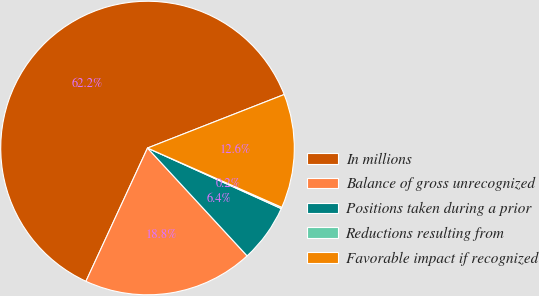<chart> <loc_0><loc_0><loc_500><loc_500><pie_chart><fcel>In millions<fcel>Balance of gross unrecognized<fcel>Positions taken during a prior<fcel>Reductions resulting from<fcel>Favorable impact if recognized<nl><fcel>62.17%<fcel>18.76%<fcel>6.36%<fcel>0.15%<fcel>12.56%<nl></chart> 